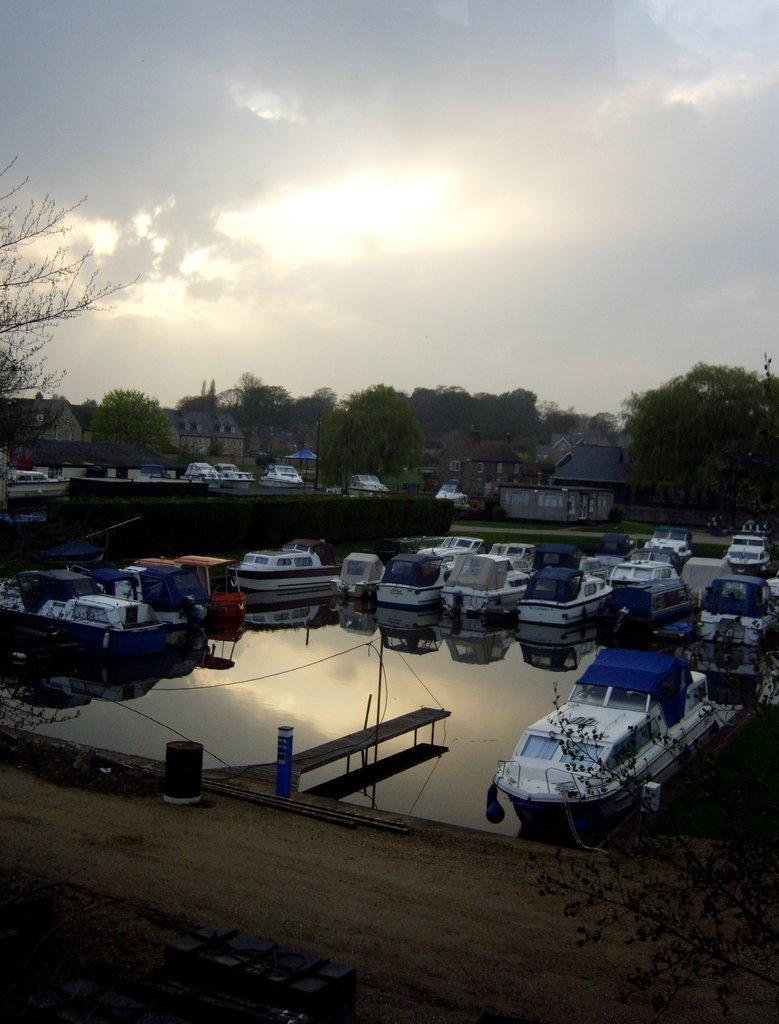How would you summarize this image in a sentence or two? In this picture there is a harbor with many white color board, parked on the water. In the front bottom there is a wooden bridge. In the background we can see some trees and boats. 